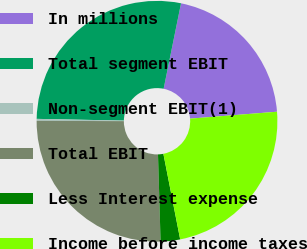Convert chart to OTSL. <chart><loc_0><loc_0><loc_500><loc_500><pie_chart><fcel>In millions<fcel>Total segment EBIT<fcel>Non-segment EBIT(1)<fcel>Total EBIT<fcel>Less Interest expense<fcel>Income before income taxes<nl><fcel>20.54%<fcel>27.88%<fcel>0.26%<fcel>25.53%<fcel>2.61%<fcel>23.18%<nl></chart> 